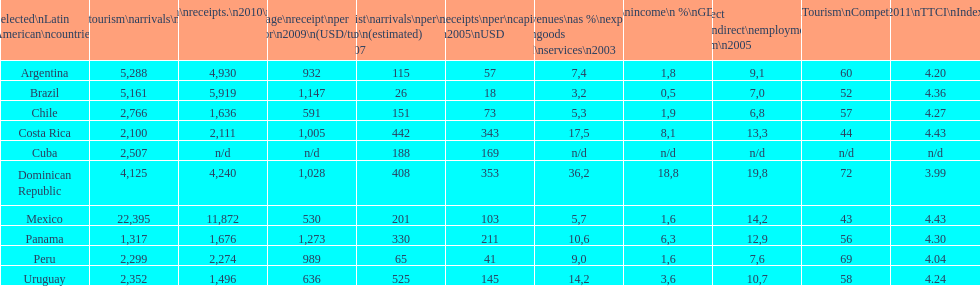What is the name of the country that had the most international tourism arrivals in 2010? Mexico. 